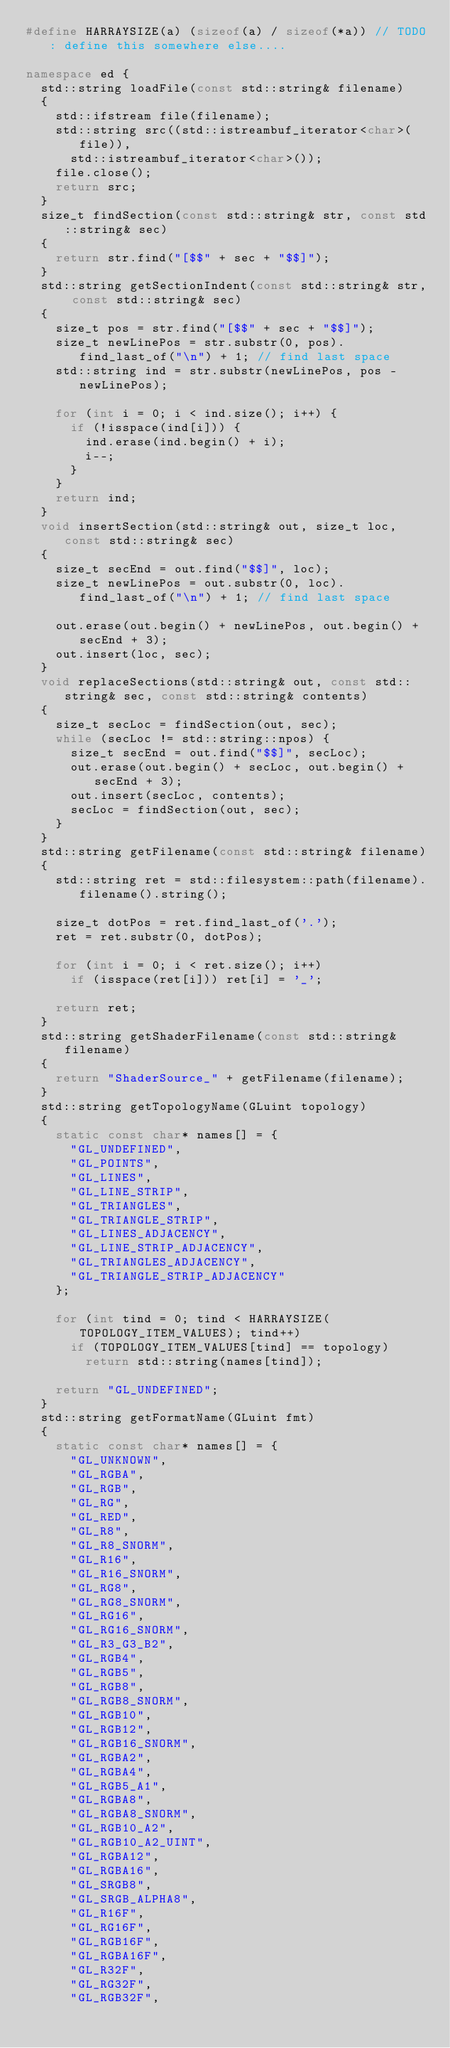Convert code to text. <code><loc_0><loc_0><loc_500><loc_500><_C++_>#define HARRAYSIZE(a) (sizeof(a) / sizeof(*a)) // TODO: define this somewhere else....

namespace ed {
	std::string loadFile(const std::string& filename)
	{
		std::ifstream file(filename);
		std::string src((std::istreambuf_iterator<char>(file)),
			std::istreambuf_iterator<char>());
		file.close();
		return src;
	}
	size_t findSection(const std::string& str, const std::string& sec)
	{
		return str.find("[$$" + sec + "$$]");
	}
	std::string getSectionIndent(const std::string& str, const std::string& sec)
	{
		size_t pos = str.find("[$$" + sec + "$$]");
		size_t newLinePos = str.substr(0, pos).find_last_of("\n") + 1; // find last space
		std::string ind = str.substr(newLinePos, pos - newLinePos);

		for (int i = 0; i < ind.size(); i++) {
			if (!isspace(ind[i])) {
				ind.erase(ind.begin() + i);
				i--;
			}
		}
		return ind;
	}
	void insertSection(std::string& out, size_t loc, const std::string& sec)
	{
		size_t secEnd = out.find("$$]", loc);
		size_t newLinePos = out.substr(0, loc).find_last_of("\n") + 1; // find last space

		out.erase(out.begin() + newLinePos, out.begin() + secEnd + 3);
		out.insert(loc, sec);
	}
	void replaceSections(std::string& out, const std::string& sec, const std::string& contents)
	{
		size_t secLoc = findSection(out, sec);
		while (secLoc != std::string::npos) {
			size_t secEnd = out.find("$$]", secLoc);
			out.erase(out.begin() + secLoc, out.begin() + secEnd + 3);
			out.insert(secLoc, contents);
			secLoc = findSection(out, sec);
		}
	}
	std::string getFilename(const std::string& filename)
	{
		std::string ret = std::filesystem::path(filename).filename().string();

		size_t dotPos = ret.find_last_of('.');
		ret = ret.substr(0, dotPos);

		for (int i = 0; i < ret.size(); i++)
			if (isspace(ret[i])) ret[i] = '_';

		return ret;
	}
	std::string getShaderFilename(const std::string& filename)
	{
		return "ShaderSource_" + getFilename(filename);
	}
	std::string getTopologyName(GLuint topology)
	{
		static const char* names[] = {
			"GL_UNDEFINED",
			"GL_POINTS",
			"GL_LINES",
			"GL_LINE_STRIP",
			"GL_TRIANGLES",
			"GL_TRIANGLE_STRIP",
			"GL_LINES_ADJACENCY",
			"GL_LINE_STRIP_ADJACENCY",
			"GL_TRIANGLES_ADJACENCY",
			"GL_TRIANGLE_STRIP_ADJACENCY"
		};

		for (int tind = 0; tind < HARRAYSIZE(TOPOLOGY_ITEM_VALUES); tind++)
			if (TOPOLOGY_ITEM_VALUES[tind] == topology)
				return std::string(names[tind]);

		return "GL_UNDEFINED";
	}
	std::string getFormatName(GLuint fmt)
	{
		static const char* names[] = {
			"GL_UNKNOWN",
			"GL_RGBA",
			"GL_RGB",
			"GL_RG",
			"GL_RED",
			"GL_R8",
			"GL_R8_SNORM",
			"GL_R16",
			"GL_R16_SNORM",
			"GL_RG8",
			"GL_RG8_SNORM",
			"GL_RG16",
			"GL_RG16_SNORM",
			"GL_R3_G3_B2",
			"GL_RGB4",
			"GL_RGB5",
			"GL_RGB8",
			"GL_RGB8_SNORM",
			"GL_RGB10",
			"GL_RGB12",
			"GL_RGB16_SNORM",
			"GL_RGBA2",
			"GL_RGBA4",
			"GL_RGB5_A1",
			"GL_RGBA8",
			"GL_RGBA8_SNORM",
			"GL_RGB10_A2",
			"GL_RGB10_A2_UINT",
			"GL_RGBA12",
			"GL_RGBA16",
			"GL_SRGB8",
			"GL_SRGB_ALPHA8",
			"GL_R16F",
			"GL_RG16F",
			"GL_RGB16F",
			"GL_RGBA16F",
			"GL_R32F",
			"GL_RG32F",
			"GL_RGB32F",</code> 